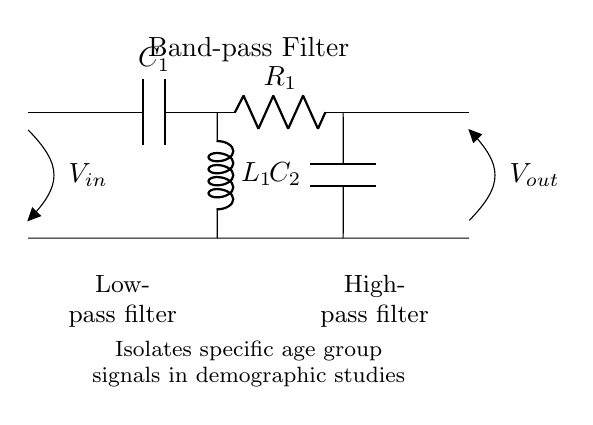What is the first component in the circuit? The first component is a capacitor labeled C1, which can be seen connected to the input voltage source and other circuit elements.
Answer: C1 What type of filter is represented in the circuit? The circuit combines both a low-pass and a high-pass filter, therefore it is a band-pass filter that isolates frequency signals within a specified range.
Answer: Band-pass filter What component follows C1 in the circuit? Following C1, R1 is connected. R1 is positioned directly after C1 and before the next stage of the circuit.
Answer: R1 How many capacitors are in this circuit? There are two capacitors in the circuit, C1 and C2, both of which serve different filtering functions in conjunction with the inductor.
Answer: 2 What does the band-pass filter specifically isolate? The band-pass filter in this circuit isolates specific age group signals, which refers to the frequency range of demographic signals in studies.
Answer: Specific age group signals What is the function of L1 in the circuit? L1, which is an inductor, functions as part of the high-pass filter, allowing higher frequencies to pass while blocking lower ones, thus shaping the overall frequency response.
Answer: High-pass filter What is the output voltage labeled as? The output voltage is labeled as Vout, indicating where the filtered signals can be taken from after processing through the circuit.
Answer: Vout 